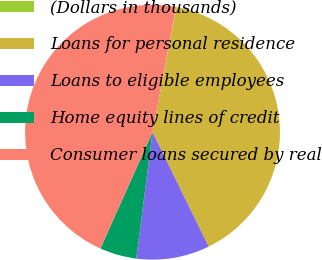<chart> <loc_0><loc_0><loc_500><loc_500><pie_chart><fcel>(Dollars in thousands)<fcel>Loans for personal residence<fcel>Loans to eligible employees<fcel>Home equity lines of credit<fcel>Consumer loans secured by real<nl><fcel>0.05%<fcel>39.74%<fcel>9.29%<fcel>4.67%<fcel>46.26%<nl></chart> 